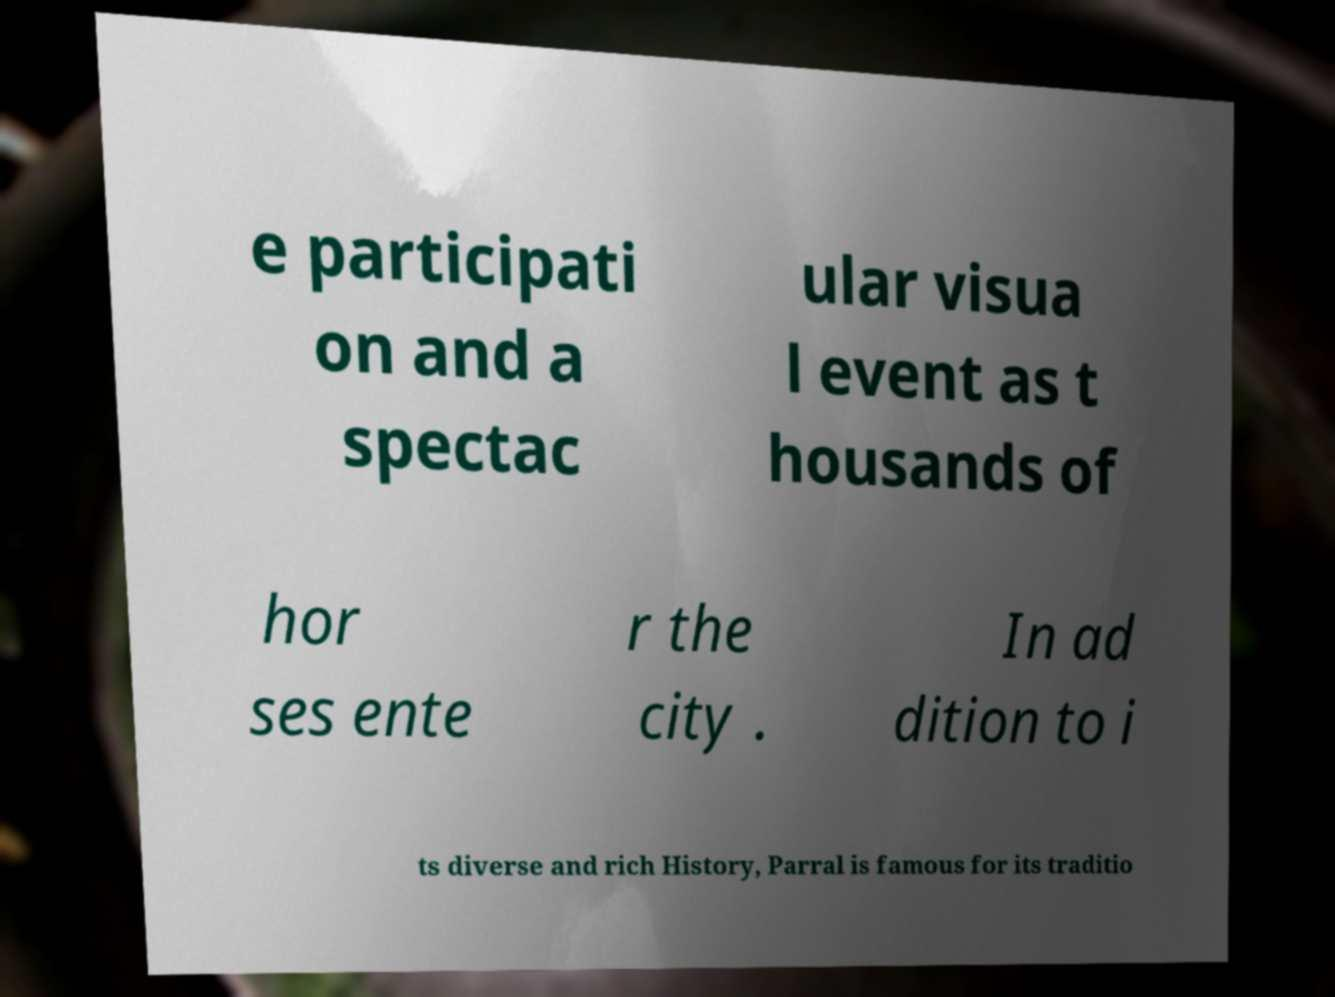Can you read and provide the text displayed in the image?This photo seems to have some interesting text. Can you extract and type it out for me? e participati on and a spectac ular visua l event as t housands of hor ses ente r the city . In ad dition to i ts diverse and rich History, Parral is famous for its traditio 